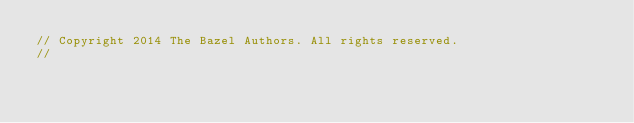<code> <loc_0><loc_0><loc_500><loc_500><_Java_>// Copyright 2014 The Bazel Authors. All rights reserved.
//</code> 